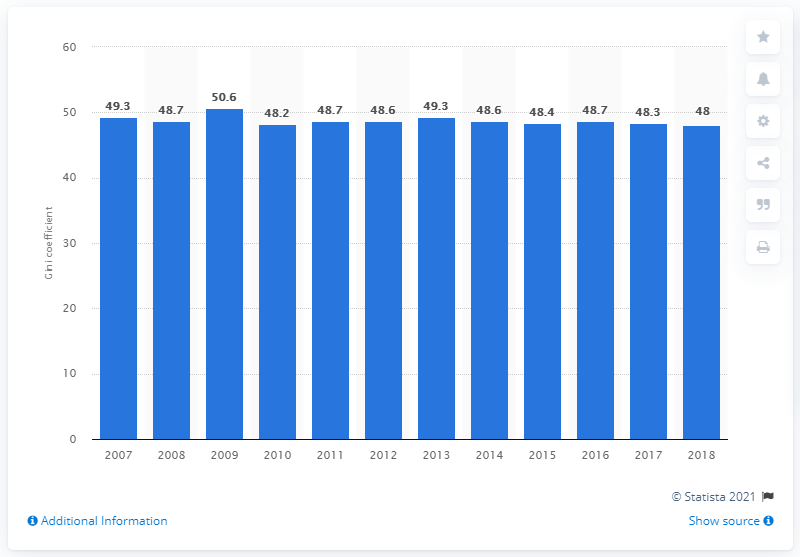Give some essential details in this illustration. Costa Rica's worst score in 2009 was 50.6. 